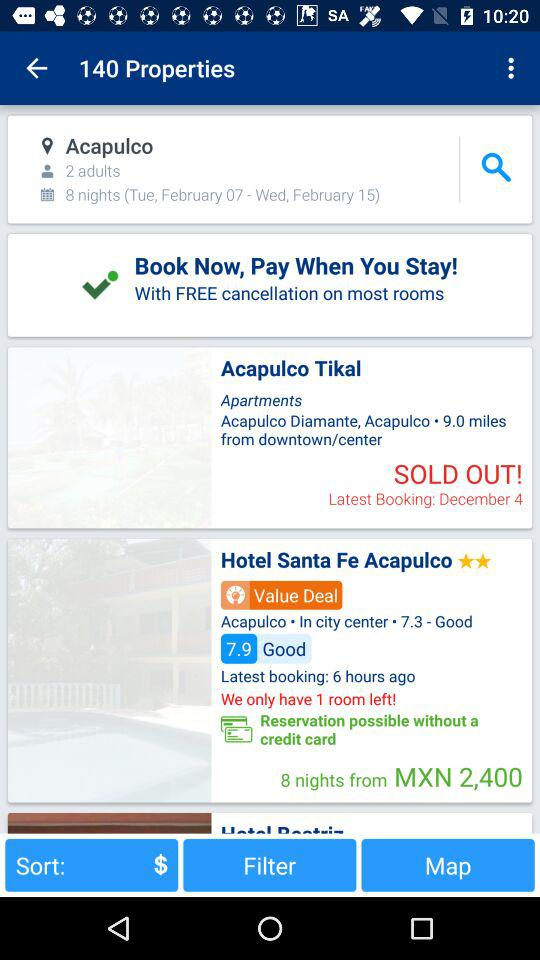When was the latest booking made at the Hotel Santa Fe Acapulco? The latest booking was made 6 hours ago. 